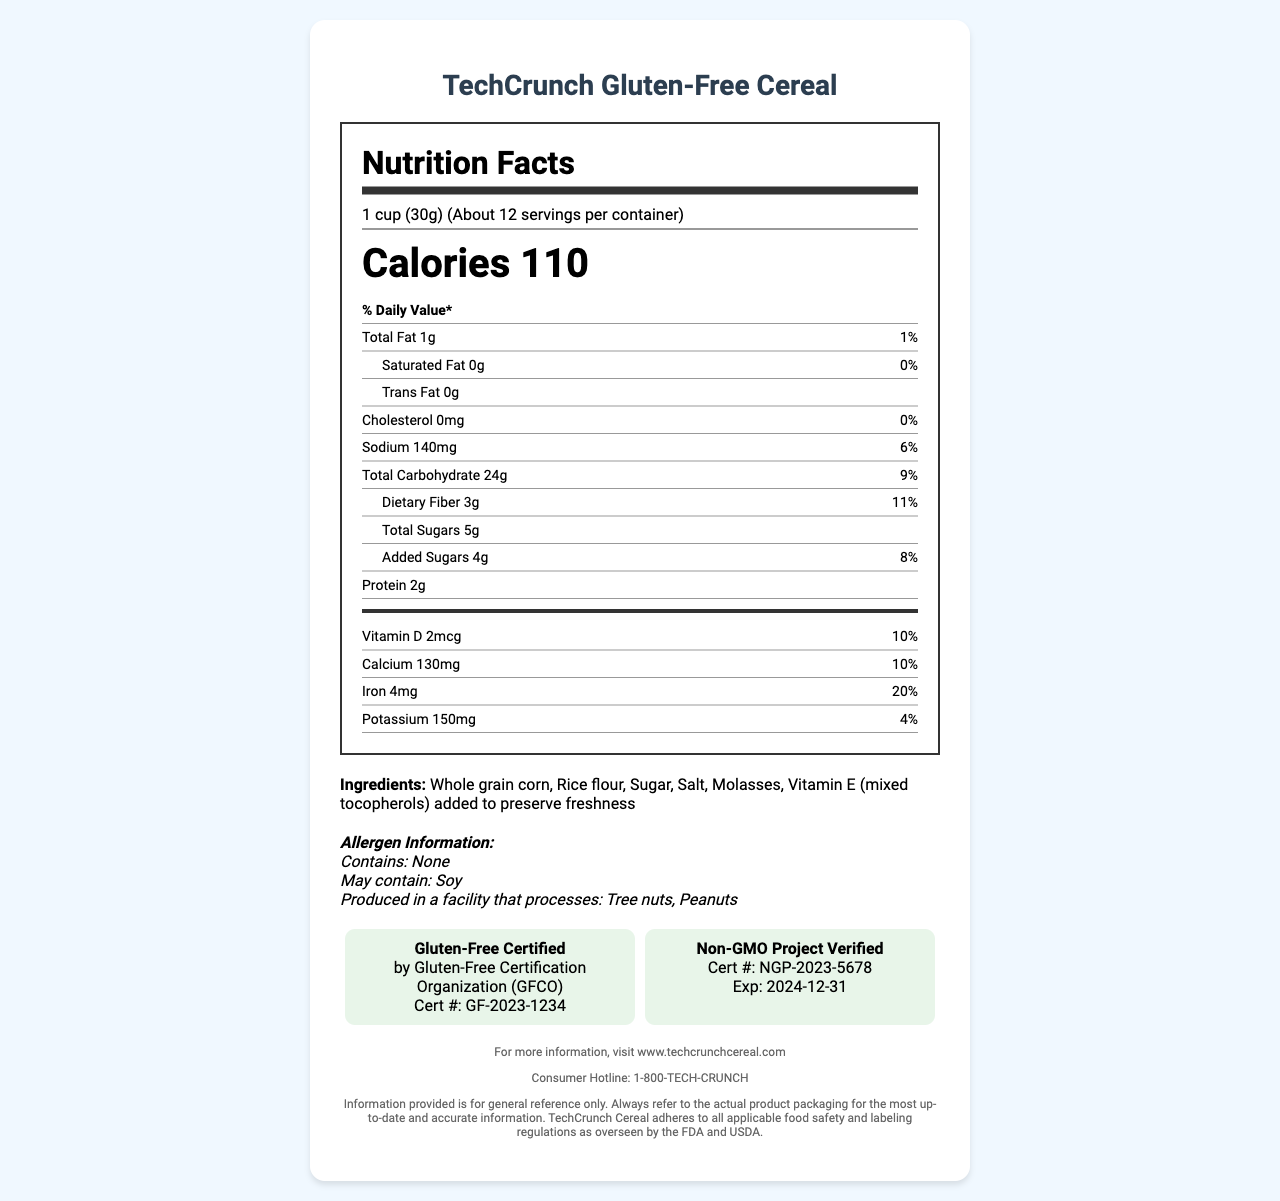what is the serving size in grams? The serving size is specified as "1 cup (30g)".
Answer: 30g how many calories are in one serving? The label states that there are 110 calories per serving.
Answer: 110 calories what is the daily value percentage of iron in one serving? The nutrition facts indicate that iron contributes 20% to the daily value per serving.
Answer: 20% name three ingredients in the cereal. The ingredients listed include whole grain corn, rice flour, and sugar among others.
Answer: Whole grain corn, Rice flour, Sugar what allergens might this product contain? The allergen information mentions that the product may contain soy.
Answer: Soy which certifying body performed the gluten-free certification? The label states the certifying body for gluten-free certification is the Gluten-Free Certification Organization (GFCO).
Answer: Gluten-Free Certification Organization (GFCO) how much potassium is in one serving and what is its daily value percentage? The potassium content is 150mg, contributing 4% to the daily value.
Answer: 150mg, 4% when is the non-GMO certification set to expire? A. 2023-12-31 B. 2024-12-31 C. 2025-12-31 The document states that the expiration date for the non-GMO certification is "2024-12-31".
Answer: B. 2024-12-31 how much added sugars does one serving contain? A. 2g B. 3g C. 4g D. 5g The added sugars in one serving amount to 4g.
Answer: C. 4g is this product manufactured in a facility that processes peanuts? The allergen information mentions that the product is produced in a facility that processes tree nuts and peanuts.
Answer: Yes provide a brief summary of the nutrition facts label for TechCrunch Gluten-Free Cereal. The label outlines the nutritional information per serving, including allergens and certifications for gluten-free and non-GMO standards. It provides batch numbers, expiration dates, and manufacturing details, along with contact and packaging sustainability information.
Answer: The TechCrunch Gluten-Free Cereal label includes information on serving size, calorie content, and various nutritional details such as fat, sugar, protein, and vitamins. It lists ingredients and allergen warnings, confirming that the product is gluten-free and non-GMO certified. The label also provides contact and sustainability information. how much trans fat is in one serving? The nutrition facts indicate that there is 0g of trans fat per serving.
Answer: 0g when was the last gluten-free certification audit conducted? The gluten-free certification's last audit date is listed as 2023-03-15.
Answer: 2023-03-15 what regulations does TechCrunch Cereal adhere to? The document specifies adherence to FDA food labeling regulations (21 CFR 101) and USDA organic regulations (7 CFR 205).
Answer: 21 CFR 101 and 7 CFR 205 how many servings are there in one container? The label indicates that there are about 12 servings per container.
Answer: About 12 what was the batch number of TechCrunch Gluten-Free Cereal? The batch number provided in the document is TC20230601.
Answer: TC20230601 what is the carbon footprint of each box? The sustainability information specifies a carbon footprint of 0.5 kg CO2e per box.
Answer: 0.5 kg CO2e what is the Vitamin D content in one serving and its daily value percentage? The label indicates that each serving contains 2mcg of Vitamin D, which contributes 10% to the daily value.
Answer: 2mcg, 10% which social media platforms can consumers find TechCrunch Gluten-Free Cereal on? A. Facebook and Twitter B. Twitter and Instagram C. Instagram and LinkedIn D. Facebook and LinkedIn The consumer information section lists the social media handles @TechCrunchCereal on Twitter and @techcrunch_cereal on Instagram.
Answer: B. Twitter and Instagram what is the sodium level per serving in milligrams? The sodium content per serving is specified as 140mg.
Answer: 140mg what is the certification number for the gluten-free certification? The gluten-free certification number provided is GF-2023-1234.
Answer: GF-2023-1234 what is the address of the manufacturing facility? The manufacturing facility's address is specified as TechFood Inc., 123 Innovation Drive, Silicon Valley, CA 94000.
Answer: TechFood Inc., 123 Innovation Drive, Silicon Valley, CA 94000 what information is not provided about the ingredients? The document does not specify the nutritional source or origin of the individual ingredients.
Answer: Nutritional source or origin of the ingredients 